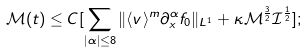Convert formula to latex. <formula><loc_0><loc_0><loc_500><loc_500>\mathcal { M } ( t ) \leq C [ \sum _ { | \alpha | \leq 8 } \| \langle v \rangle ^ { m } \partial _ { x } ^ { \alpha } f _ { 0 } \| _ { L ^ { 1 } } + \kappa \mathcal { M } ^ { \frac { 3 } { 2 } } \mathcal { I } ^ { \frac { 1 } { 2 } } ] ;</formula> 